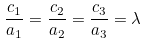Convert formula to latex. <formula><loc_0><loc_0><loc_500><loc_500>\frac { c _ { 1 } } { a _ { 1 } } = \frac { c _ { 2 } } { a _ { 2 } } = \frac { c _ { 3 } } { a _ { 3 } } = \lambda</formula> 